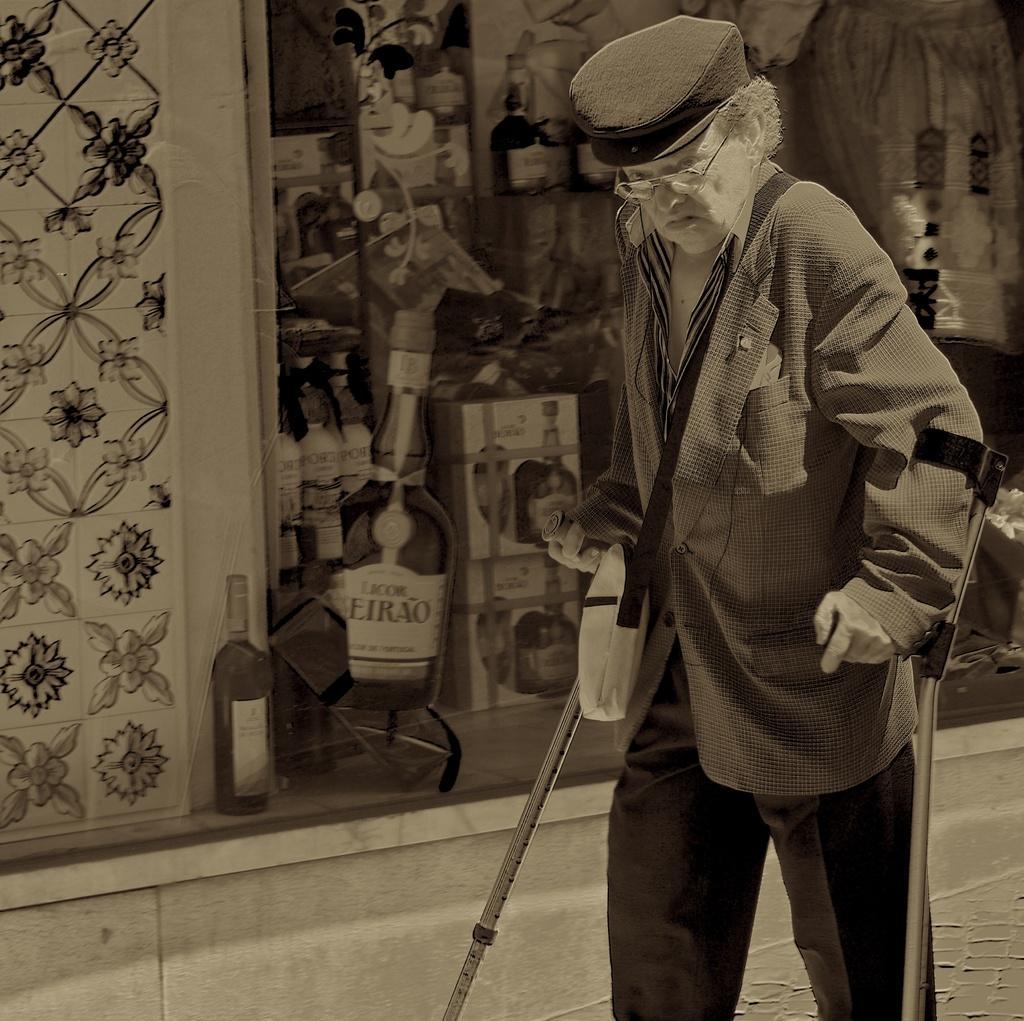In one or two sentences, can you explain what this image depicts? In this image I can see a person wearing jacket, pant and hat is standing and holding sticks in his hand. In the background I can see the wall, a bottle and the glass surface through which I can see few objects. 